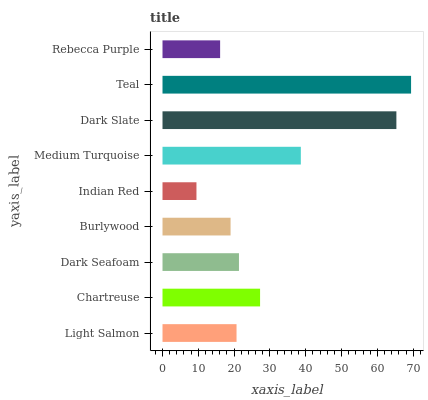Is Indian Red the minimum?
Answer yes or no. Yes. Is Teal the maximum?
Answer yes or no. Yes. Is Chartreuse the minimum?
Answer yes or no. No. Is Chartreuse the maximum?
Answer yes or no. No. Is Chartreuse greater than Light Salmon?
Answer yes or no. Yes. Is Light Salmon less than Chartreuse?
Answer yes or no. Yes. Is Light Salmon greater than Chartreuse?
Answer yes or no. No. Is Chartreuse less than Light Salmon?
Answer yes or no. No. Is Dark Seafoam the high median?
Answer yes or no. Yes. Is Dark Seafoam the low median?
Answer yes or no. Yes. Is Rebecca Purple the high median?
Answer yes or no. No. Is Burlywood the low median?
Answer yes or no. No. 